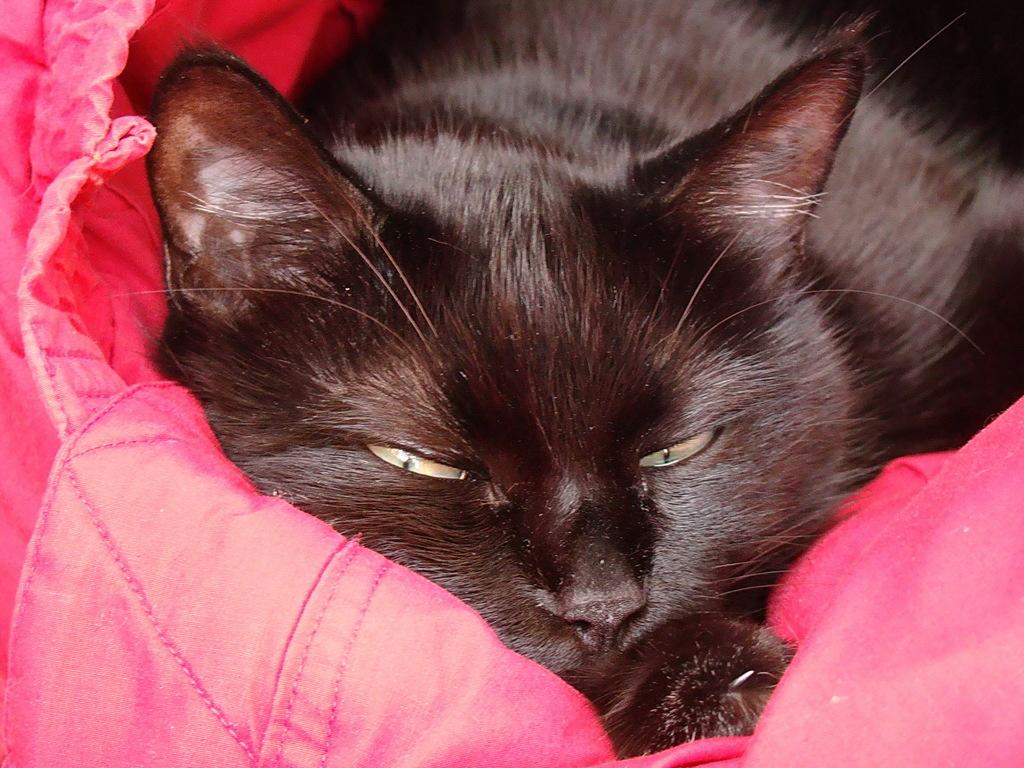What type of animal is in the image? There is a cat in the image. What color is the cat? The cat is black in color. What is the cat lying on? The cat is lying on a pink blanket. What type of metal is the cat using as a guide in the image? There is no metal or guide present in the image; it features a black cat lying on a pink blanket. 